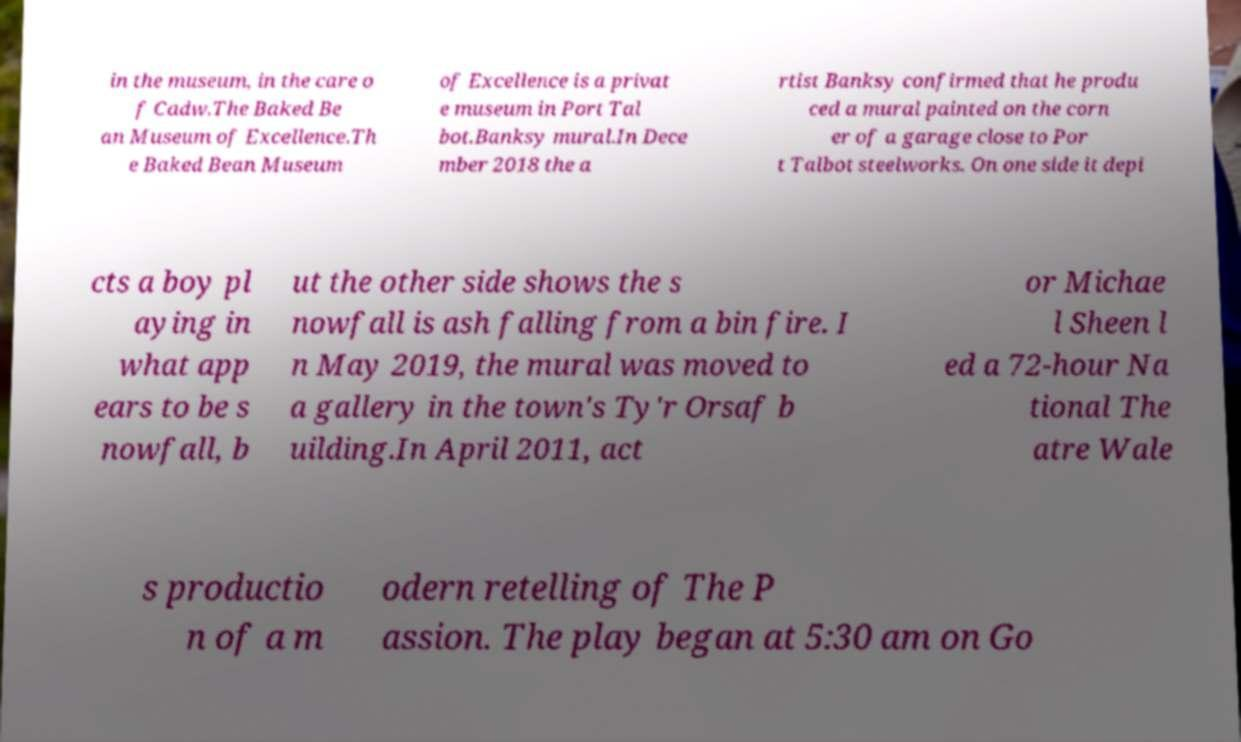Could you extract and type out the text from this image? in the museum, in the care o f Cadw.The Baked Be an Museum of Excellence.Th e Baked Bean Museum of Excellence is a privat e museum in Port Tal bot.Banksy mural.In Dece mber 2018 the a rtist Banksy confirmed that he produ ced a mural painted on the corn er of a garage close to Por t Talbot steelworks. On one side it depi cts a boy pl aying in what app ears to be s nowfall, b ut the other side shows the s nowfall is ash falling from a bin fire. I n May 2019, the mural was moved to a gallery in the town's Ty'r Orsaf b uilding.In April 2011, act or Michae l Sheen l ed a 72-hour Na tional The atre Wale s productio n of a m odern retelling of The P assion. The play began at 5:30 am on Go 